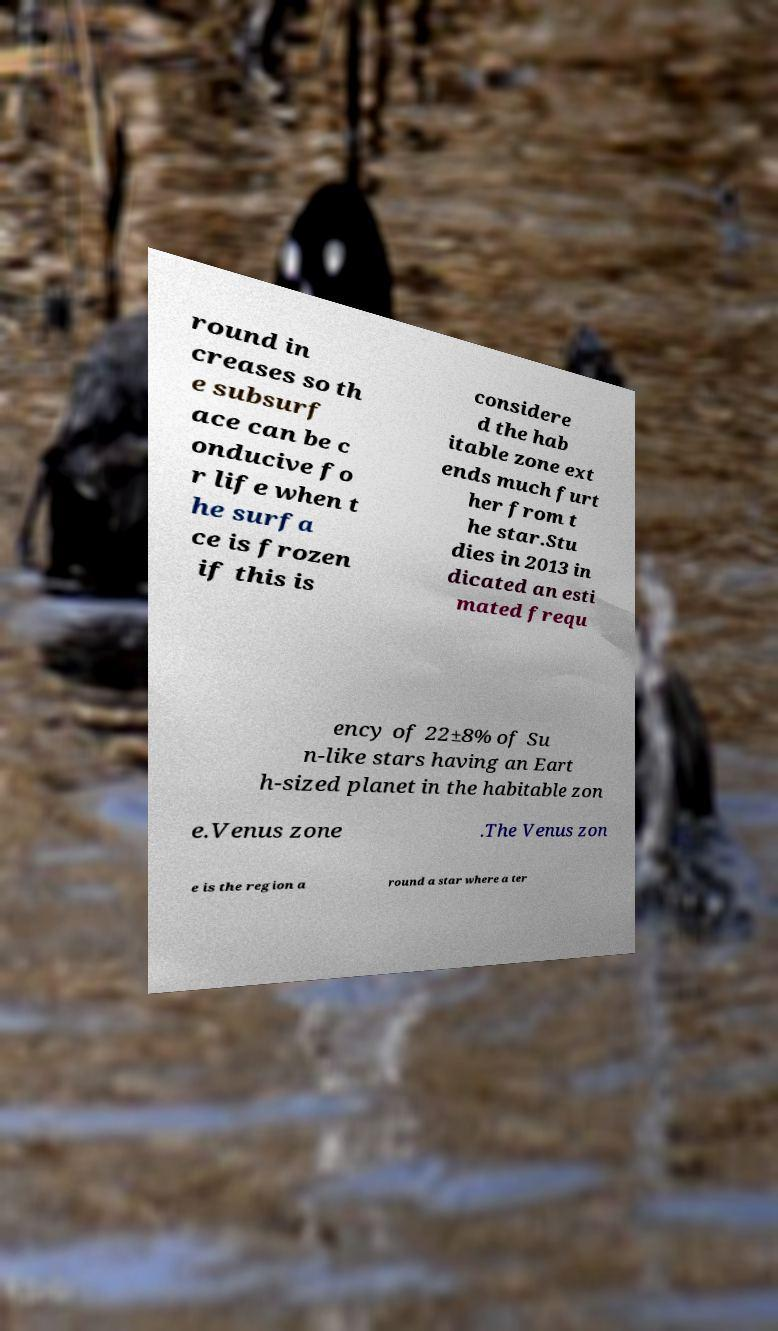Please read and relay the text visible in this image. What does it say? round in creases so th e subsurf ace can be c onducive fo r life when t he surfa ce is frozen if this is considere d the hab itable zone ext ends much furt her from t he star.Stu dies in 2013 in dicated an esti mated frequ ency of 22±8% of Su n-like stars having an Eart h-sized planet in the habitable zon e.Venus zone .The Venus zon e is the region a round a star where a ter 